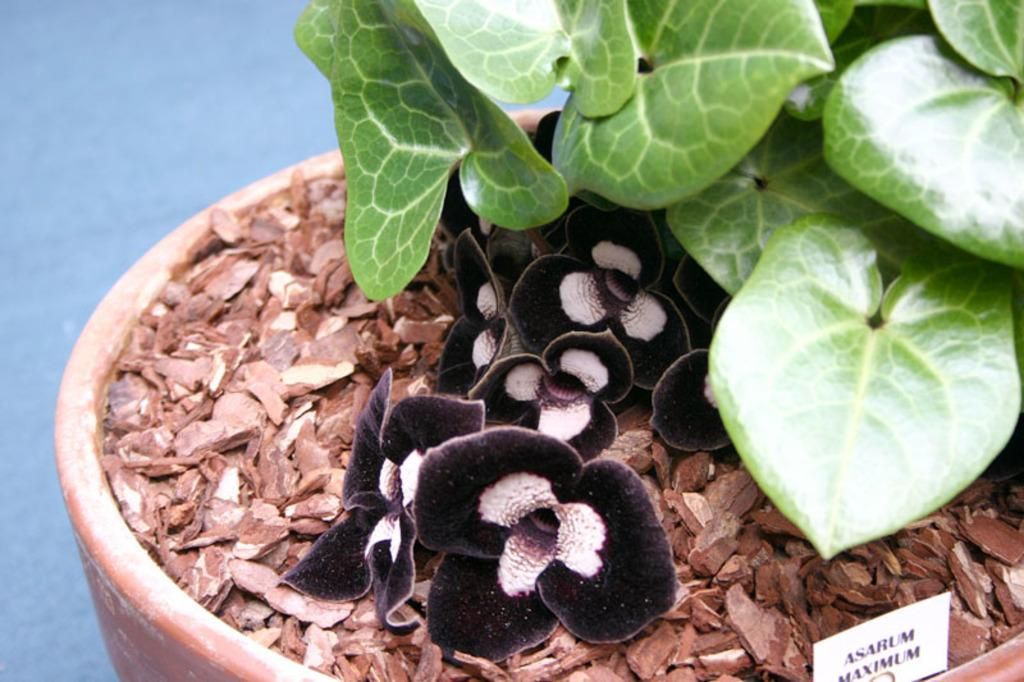What type of living organism can be seen in the image? There is a plant in the image. What is the other object made of in the image? There is a paper in the image. What additional feature can be seen on the plant? There are flowers in the image. Where is the monkey sitting in the image? There is no monkey present in the image. What type of market can be seen in the background of the image? There is no market present in the image. 